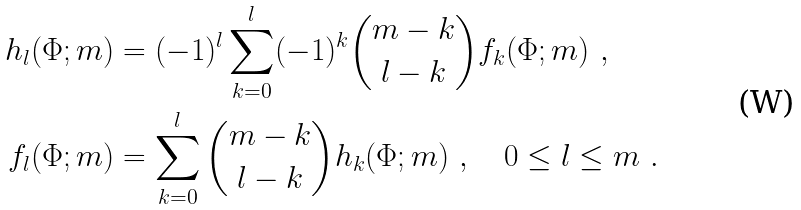<formula> <loc_0><loc_0><loc_500><loc_500>h _ { l } ( \Phi ; m ) & = ( - 1 ) ^ { l } \sum _ { k = 0 } ^ { l } ( - 1 ) ^ { k } \binom { m - k } { l - k } f _ { k } ( \Phi ; m ) \ , \\ f _ { l } ( \Phi ; m ) & = \sum _ { k = 0 } ^ { l } \binom { m - k } { l - k } h _ { k } ( \Phi ; m ) \ , \quad 0 \leq l \leq m \ .</formula> 